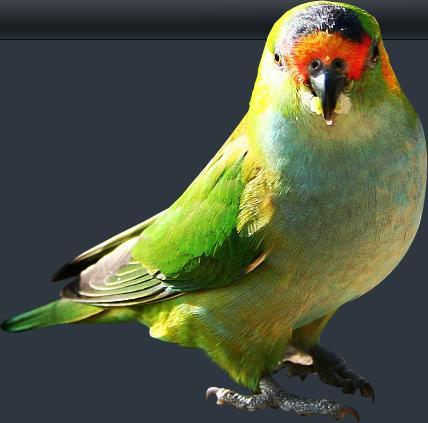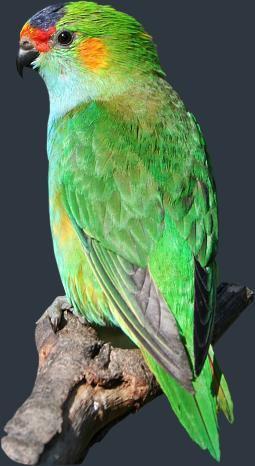The first image is the image on the left, the second image is the image on the right. For the images shown, is this caption "There are exactly two birds in one of the images." true? Answer yes or no. No. The first image is the image on the left, the second image is the image on the right. Given the left and right images, does the statement "All green parrots have orange chest areas." hold true? Answer yes or no. No. 